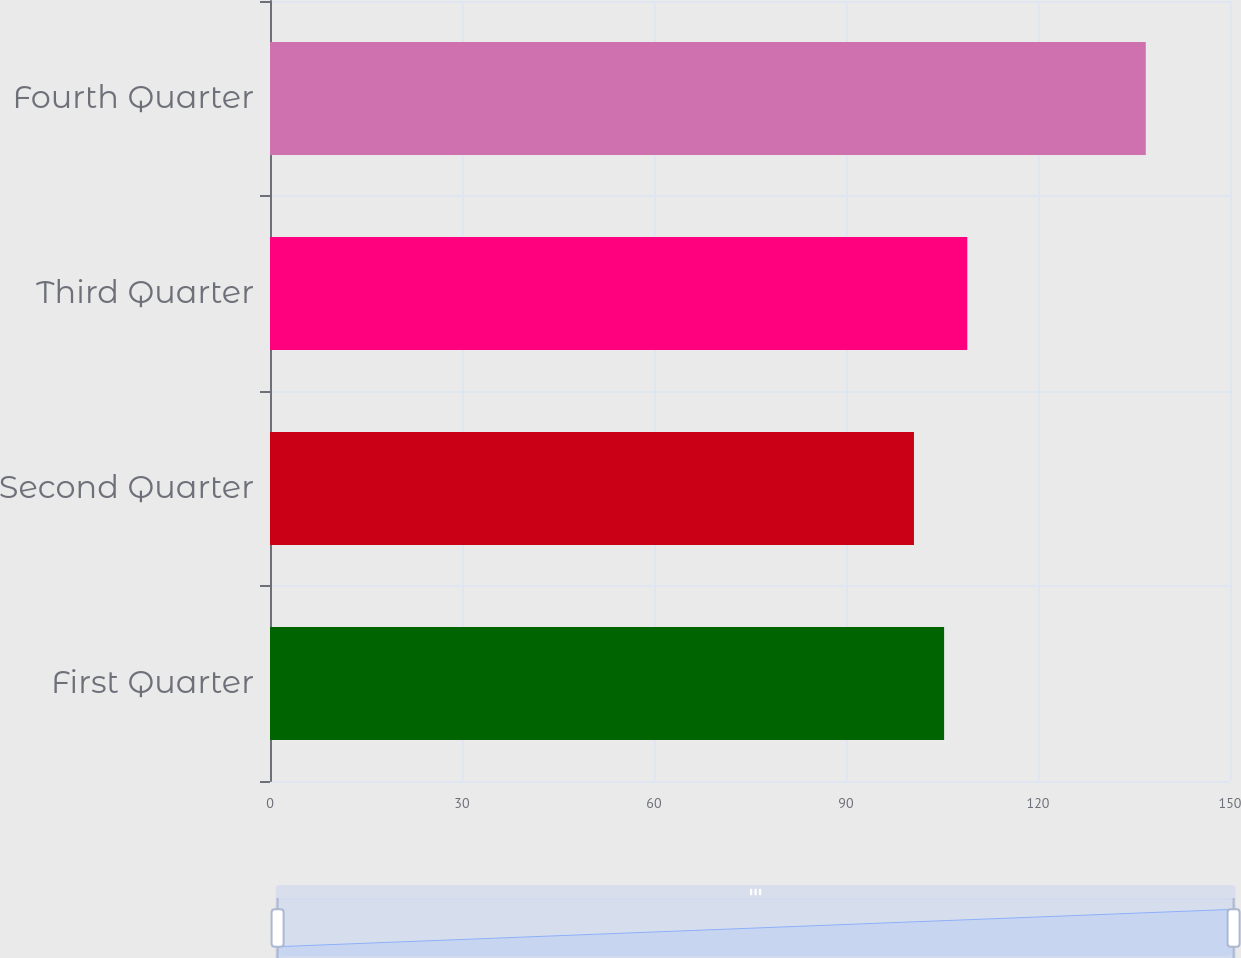<chart> <loc_0><loc_0><loc_500><loc_500><bar_chart><fcel>First Quarter<fcel>Second Quarter<fcel>Third Quarter<fcel>Fourth Quarter<nl><fcel>105.33<fcel>100.62<fcel>108.95<fcel>136.84<nl></chart> 